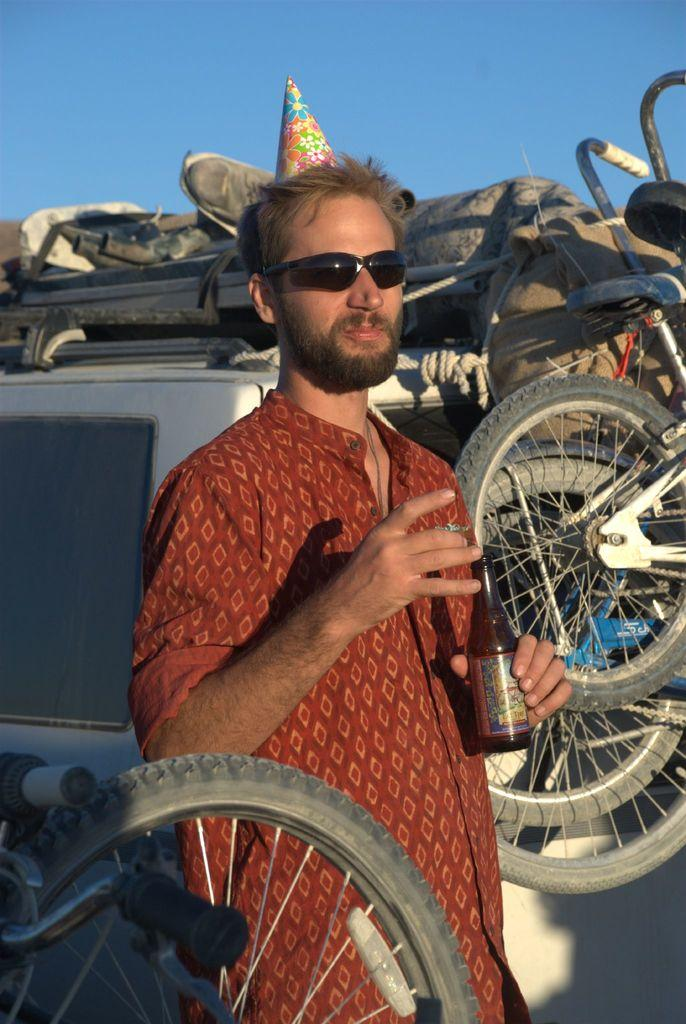What types of vehicles are in the image? The image contains vehicles, but the specific types are not mentioned. What personal object can be seen in the image? There is a personal object in the image, but its nature is not specified. What is the bottle in the image used for? The purpose of the bottle in the image is not mentioned. What is the cap in the image used for? The purpose of the cap in the image is not mentioned. What is the person holding in the image? The person is holding a bottle in the image. What protective gear is the person wearing in the image? The person is wearing goggles in the image. What can be seen in the background of the image? The sky is visible in the background of the image. What type of wave can be seen crashing on the shore in the image? There is no reference to a shore or a wave in the image. How many teeth can be seen in the person's mouth in the image? The image does not show the person's teeth, so it is not possible to determine the number of teeth. 